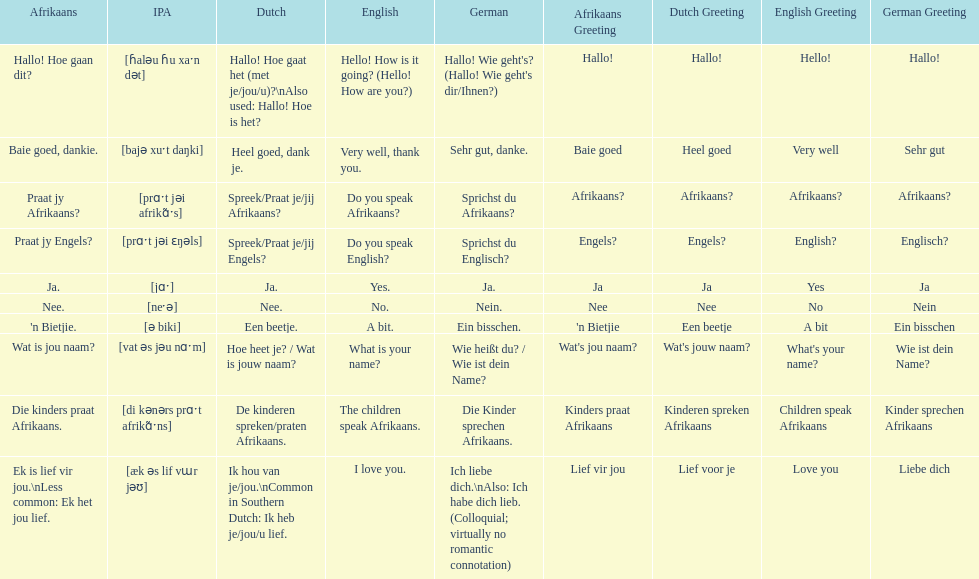Translate the following into german: die kinders praat afrikaans. Die Kinder sprechen Afrikaans. 